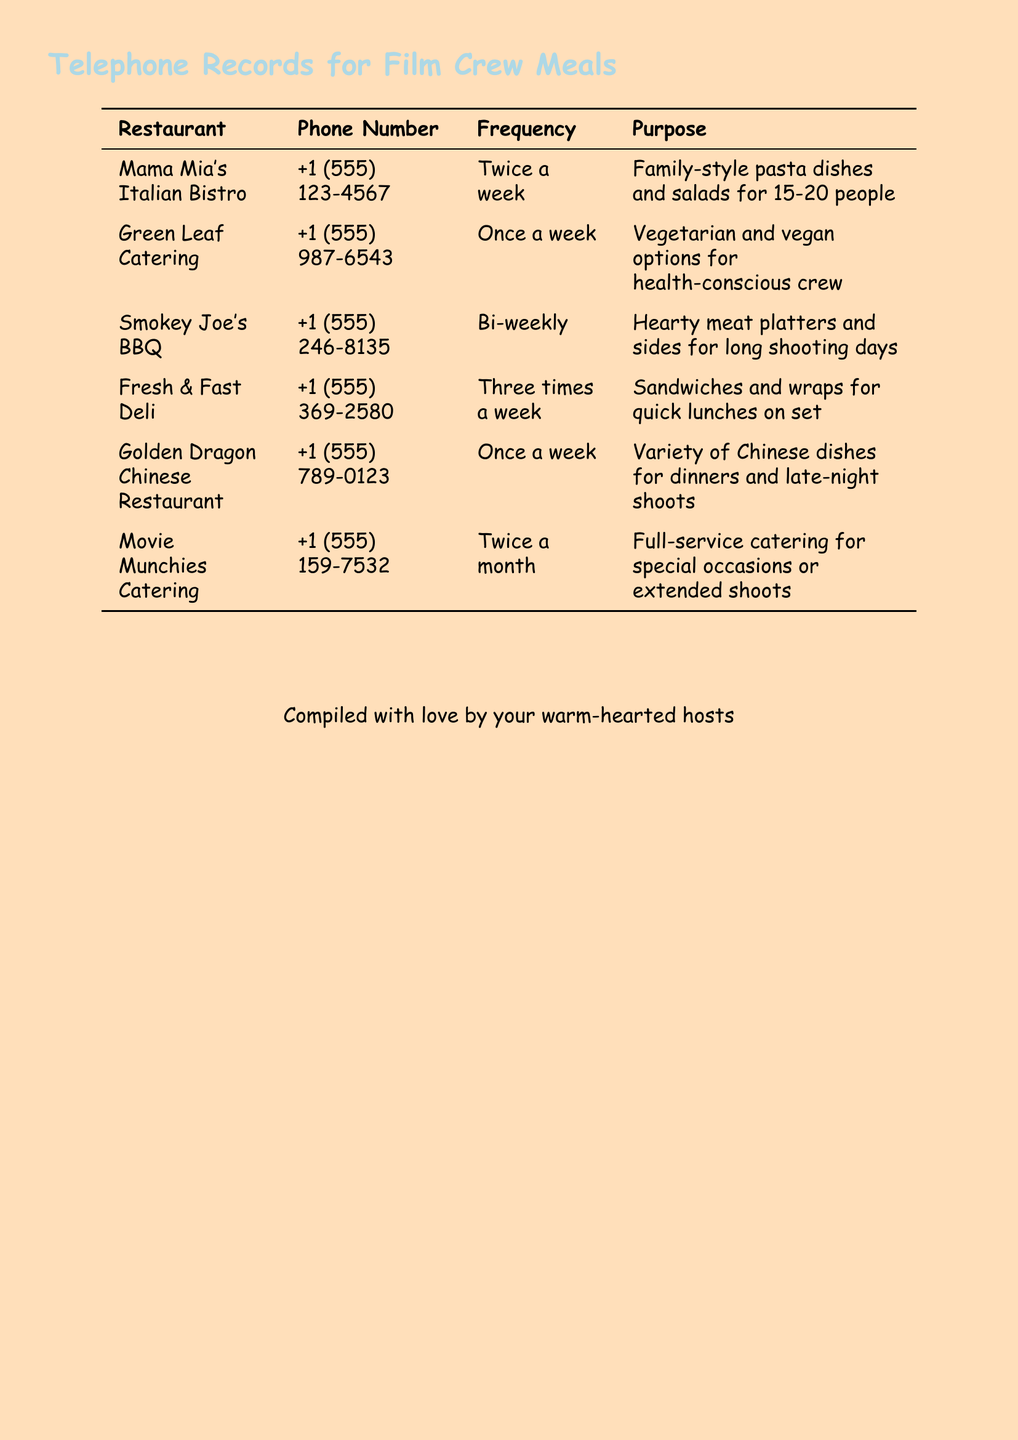what is the name of the Italian restaurant? The name of the Italian restaurant is listed in the document as the first entry under Restaurant.
Answer: Mama Mia's Italian Bistro how often does Green Leaf Catering get called? The document specifies the frequency of calls for Green Leaf Catering in the Frequency column, which indicates how often they are contacted.
Answer: Once a week what type of cuisine does Smokey Joe's BBQ provide? The document mentions the type of food offered by Smokey Joe's BBQ in the Purpose column, providing insight on their cuisine type.
Answer: Hearty meat platters how many times a week Fresh & Fast Deli is contacted? The document states the frequency of calls for Fresh & Fast Deli in the Frequency column.
Answer: Three times a week which restaurant is contacted bi-weekly? The frequency of calls for each restaurant is detailed in the document, helping to identify which restaurant falls under bi-weekly contact.
Answer: Smokey Joe's BBQ what is the phone number for Movie Munchies Catering? The phone number for Movie Munchies Catering is listed in the document under Phone Number, providing direct contact information.
Answer: +1 (555) 159-7532 for what purpose is Golden Dragon Chinese Restaurant called? The document outlines the specific reasons or purposes for contacting each restaurant in the Purpose column, clarifying their services.
Answer: Variety of Chinese dishes how many restaurants provide vegetarian options? By analyzing the Purpose column, the document reveals how many of the listed restaurants specifically mention vegetarian offerings.
Answer: One 